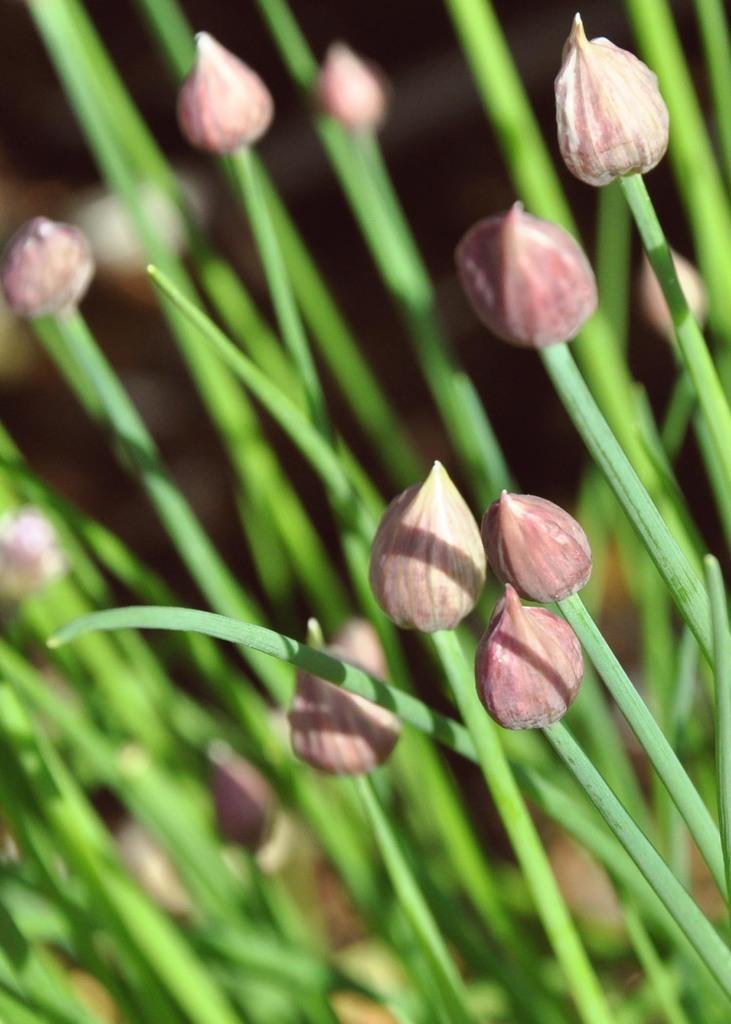What type of living organisms can be seen in the image? Plants can be seen in the image. Do the plants in the image have any specific features? Yes, the plants have flowers. What type of fiction is the plant wearing in the image? There is no apparel present on the plants in the image, as plants do not wear clothing. 